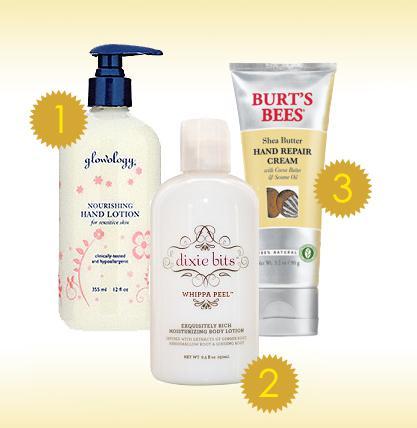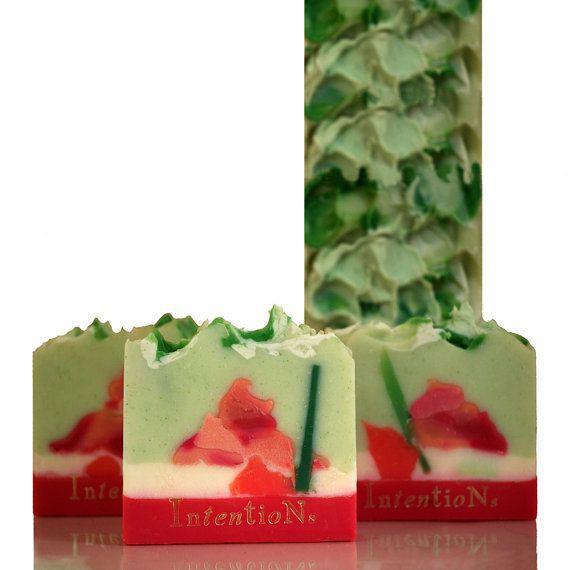The first image is the image on the left, the second image is the image on the right. Assess this claim about the two images: "There is a tall bottle with a pump.". Correct or not? Answer yes or no. Yes. The first image is the image on the left, the second image is the image on the right. Given the left and right images, does the statement "Each image includes products posed with sprig-type things from nature." hold true? Answer yes or no. No. 